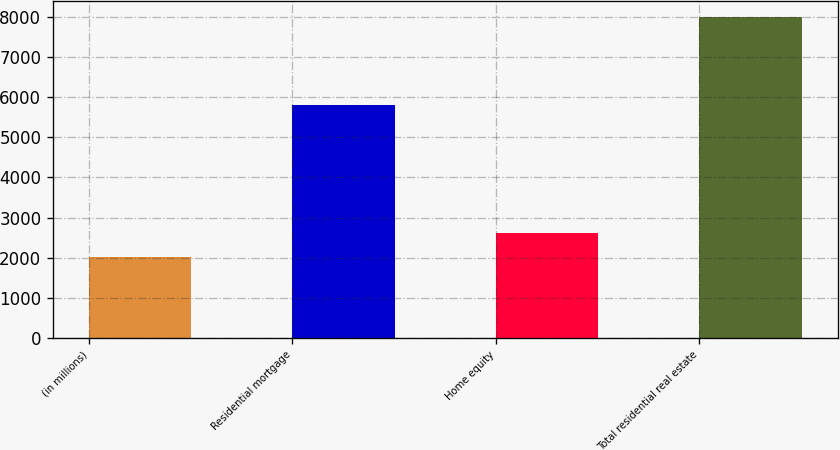Convert chart to OTSL. <chart><loc_0><loc_0><loc_500><loc_500><bar_chart><fcel>(in millions)<fcel>Residential mortgage<fcel>Home equity<fcel>Total residential real estate<nl><fcel>2017<fcel>5797<fcel>2613.9<fcel>7986<nl></chart> 